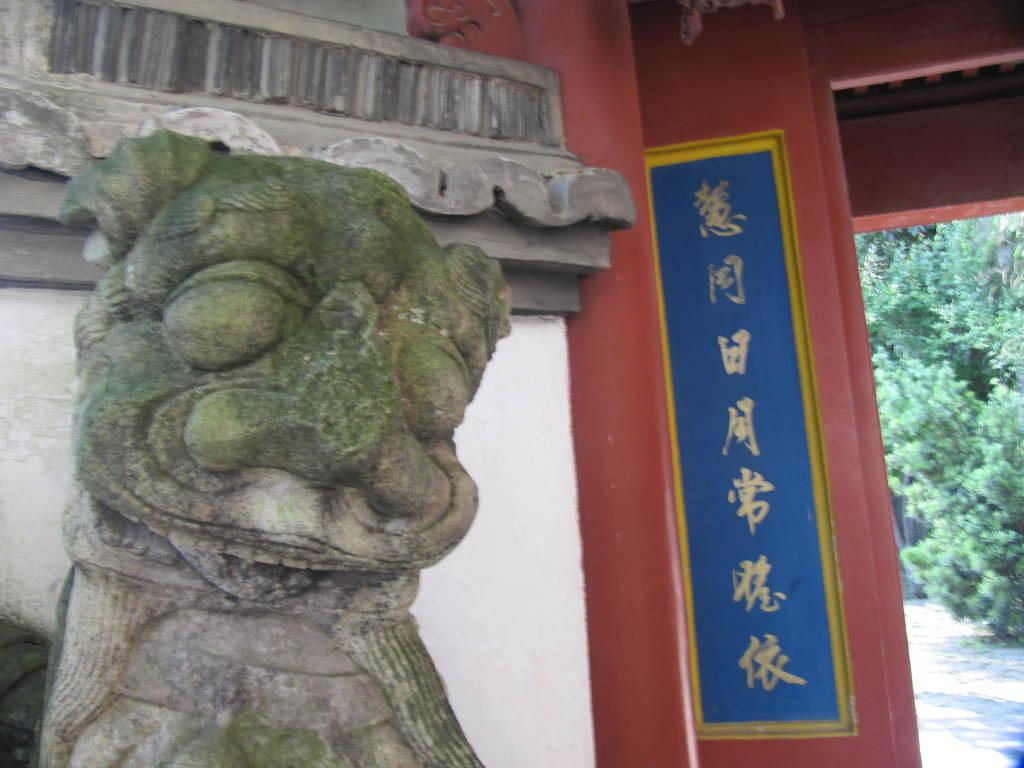What is the main subject of the image? The main subject of the image is a sculpture made up of stones. What is the sculpture possibly associated with? The sculpture is likely to be a part of a poster. What type of path can be seen in the image? There is a footpath in the image. What type of vegetation is visible in the image? There are trees in the image. Can you tell me where the stranger is standing in the image? There is no stranger present in the image. What direction is the meeting taking place in the image? There is no meeting depicted in the image. 